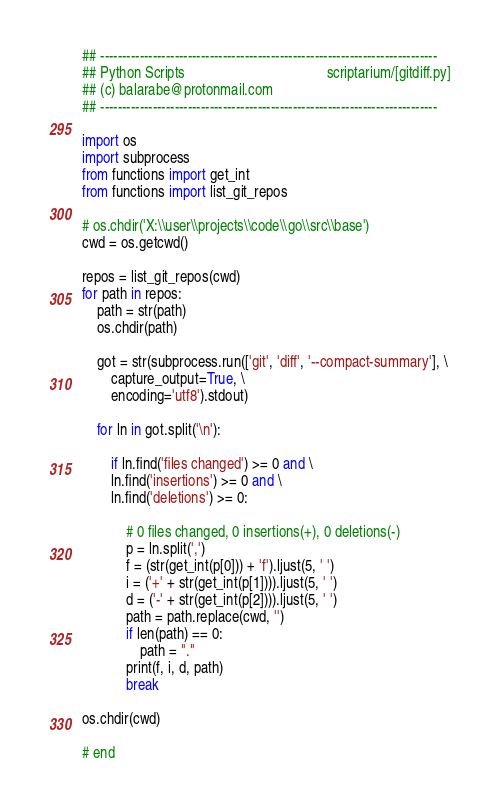Convert code to text. <code><loc_0><loc_0><loc_500><loc_500><_Python_>## -----------------------------------------------------------------------------
## Python Scripts                                       scriptarium/[gitdiff.py]
## (c) balarabe@protonmail.com
## -----------------------------------------------------------------------------

import os
import subprocess
from functions import get_int
from functions import list_git_repos

# os.chdir('X:\\user\\projects\\code\\go\\src\\base')
cwd = os.getcwd()

repos = list_git_repos(cwd)
for path in repos:
    path = str(path)
    os.chdir(path)

    got = str(subprocess.run(['git', 'diff', '--compact-summary'], \
        capture_output=True, \
        encoding='utf8').stdout)

    for ln in got.split('\n'):

        if ln.find('files changed') >= 0 and \
        ln.find('insertions') >= 0 and \
        ln.find('deletions') >= 0:

            # 0 files changed, 0 insertions(+), 0 deletions(-)
            p = ln.split(',')
            f = (str(get_int(p[0])) + 'f').ljust(5, ' ')
            i = ('+' + str(get_int(p[1]))).ljust(5, ' ')
            d = ('-' + str(get_int(p[2]))).ljust(5, ' ')
            path = path.replace(cwd, '')
            if len(path) == 0:
                path = "."
            print(f, i, d, path)
            break

os.chdir(cwd)

# end
</code> 